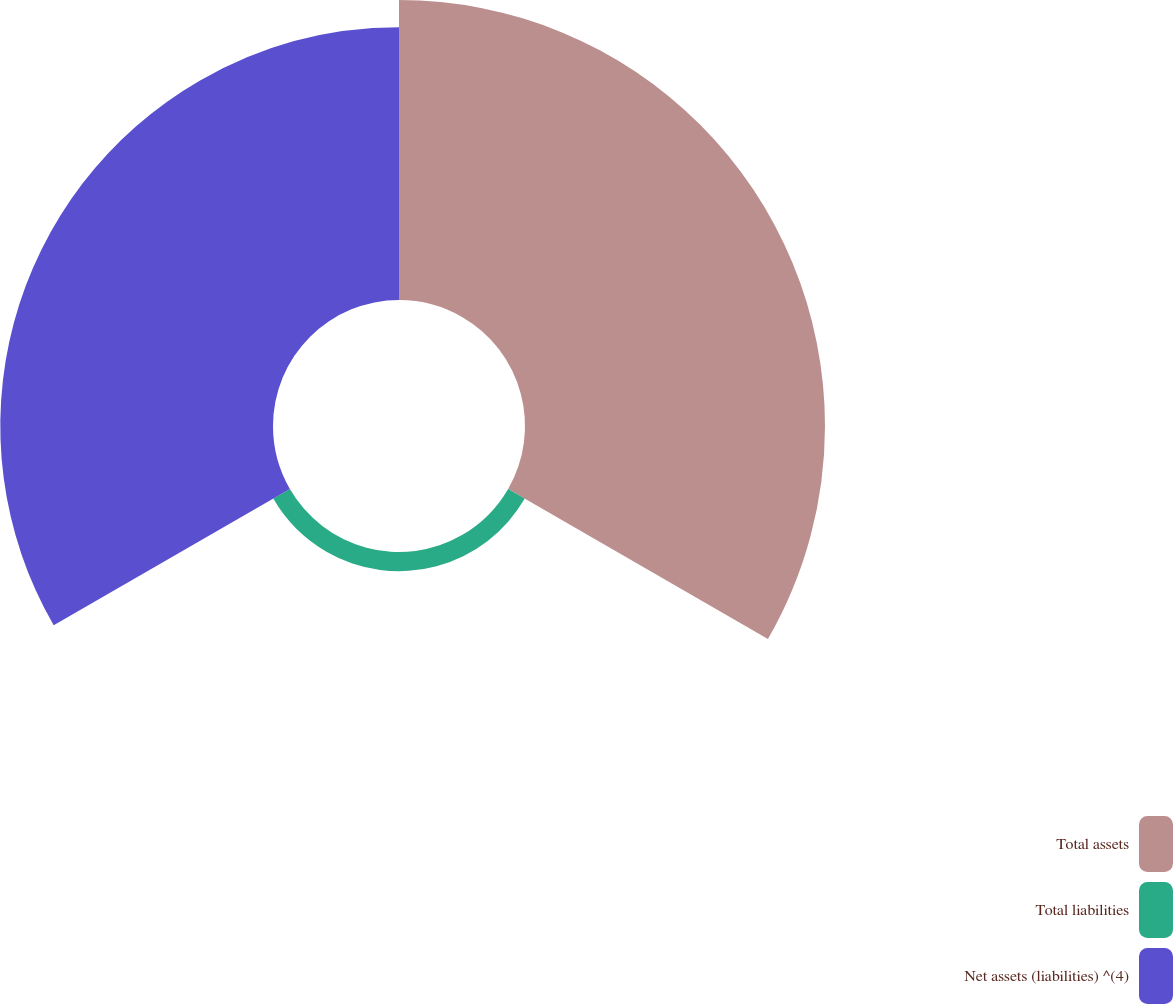Convert chart to OTSL. <chart><loc_0><loc_0><loc_500><loc_500><pie_chart><fcel>Total assets<fcel>Total liabilities<fcel>Net assets (liabilities) ^(4)<nl><fcel>50.68%<fcel>3.24%<fcel>46.07%<nl></chart> 